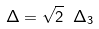<formula> <loc_0><loc_0><loc_500><loc_500>\Delta = \sqrt { 2 } \ \Delta _ { 3 }</formula> 